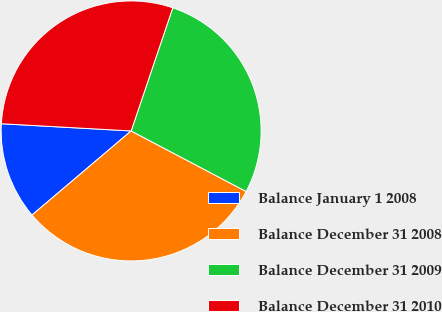Convert chart. <chart><loc_0><loc_0><loc_500><loc_500><pie_chart><fcel>Balance January 1 2008<fcel>Balance December 31 2008<fcel>Balance December 31 2009<fcel>Balance December 31 2010<nl><fcel>12.08%<fcel>31.09%<fcel>27.53%<fcel>29.31%<nl></chart> 